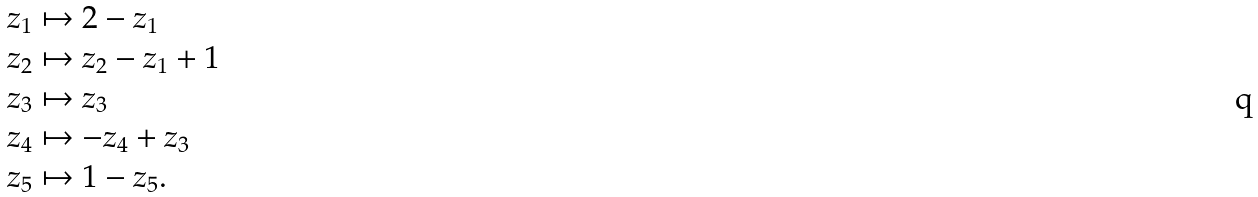Convert formula to latex. <formula><loc_0><loc_0><loc_500><loc_500>z _ { 1 } & \mapsto 2 - z _ { 1 } \\ z _ { 2 } & \mapsto z _ { 2 } - z _ { 1 } + 1 \\ z _ { 3 } & \mapsto z _ { 3 } \\ z _ { 4 } & \mapsto - z _ { 4 } + z _ { 3 } \\ z _ { 5 } & \mapsto 1 - z _ { 5 } .</formula> 